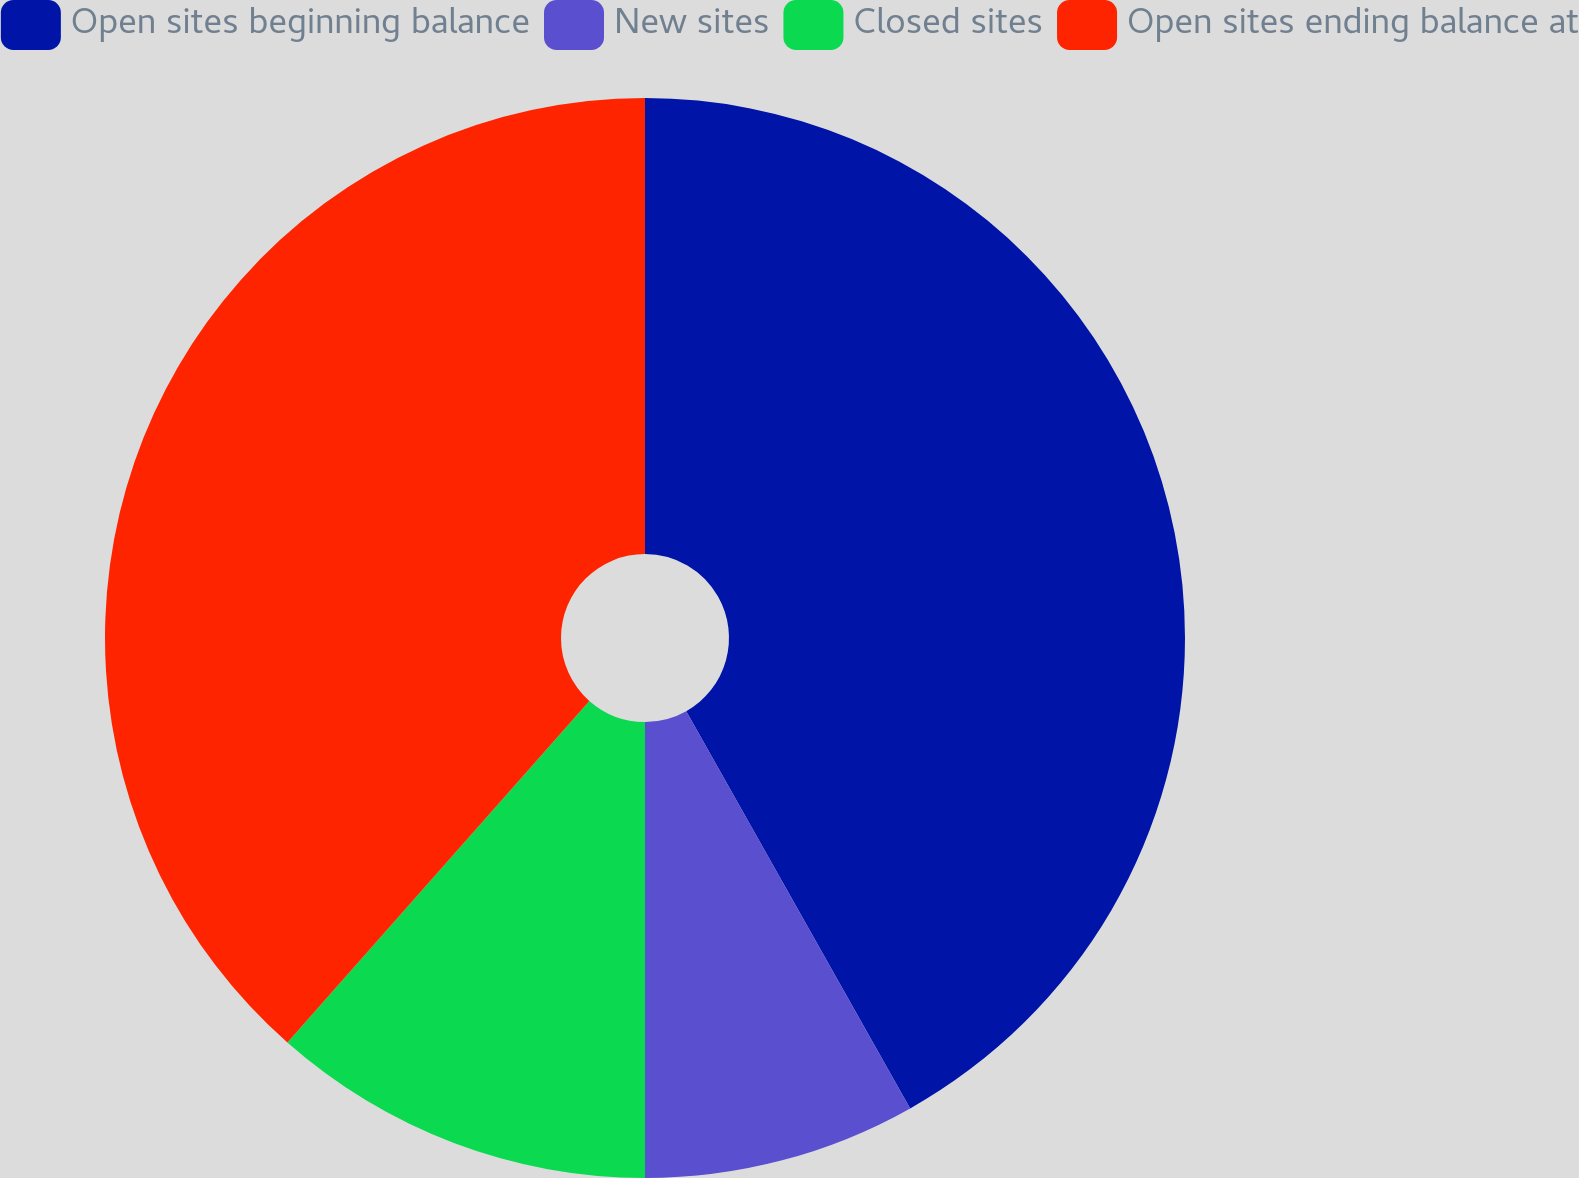Convert chart. <chart><loc_0><loc_0><loc_500><loc_500><pie_chart><fcel>Open sites beginning balance<fcel>New sites<fcel>Closed sites<fcel>Open sites ending balance at<nl><fcel>41.83%<fcel>8.17%<fcel>11.52%<fcel>38.48%<nl></chart> 